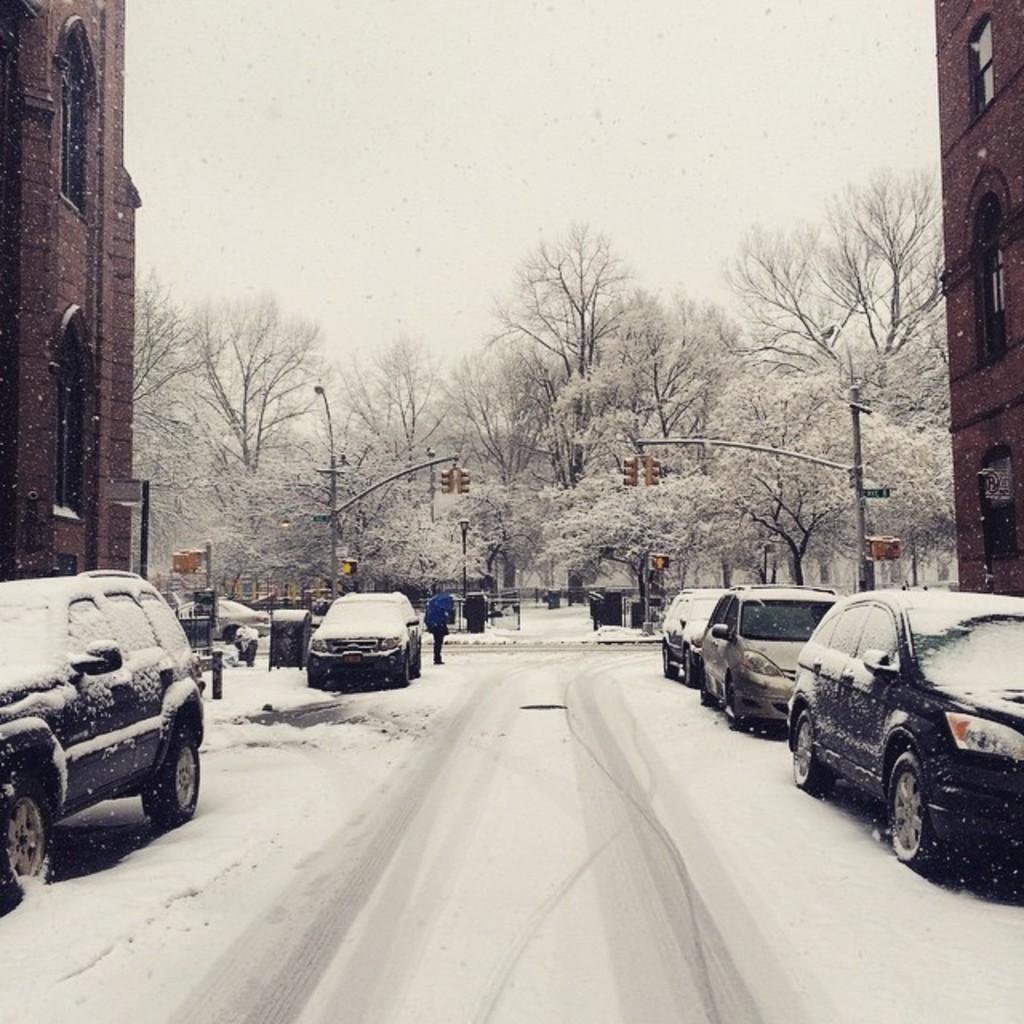Please provide a concise description of this image. In this image I can see the snow on the road and few vehicles. I can see snow on the vehicles. In the background I can see few trees, few poles, few traffic signals, few persons standing, few buildings and the sky. 